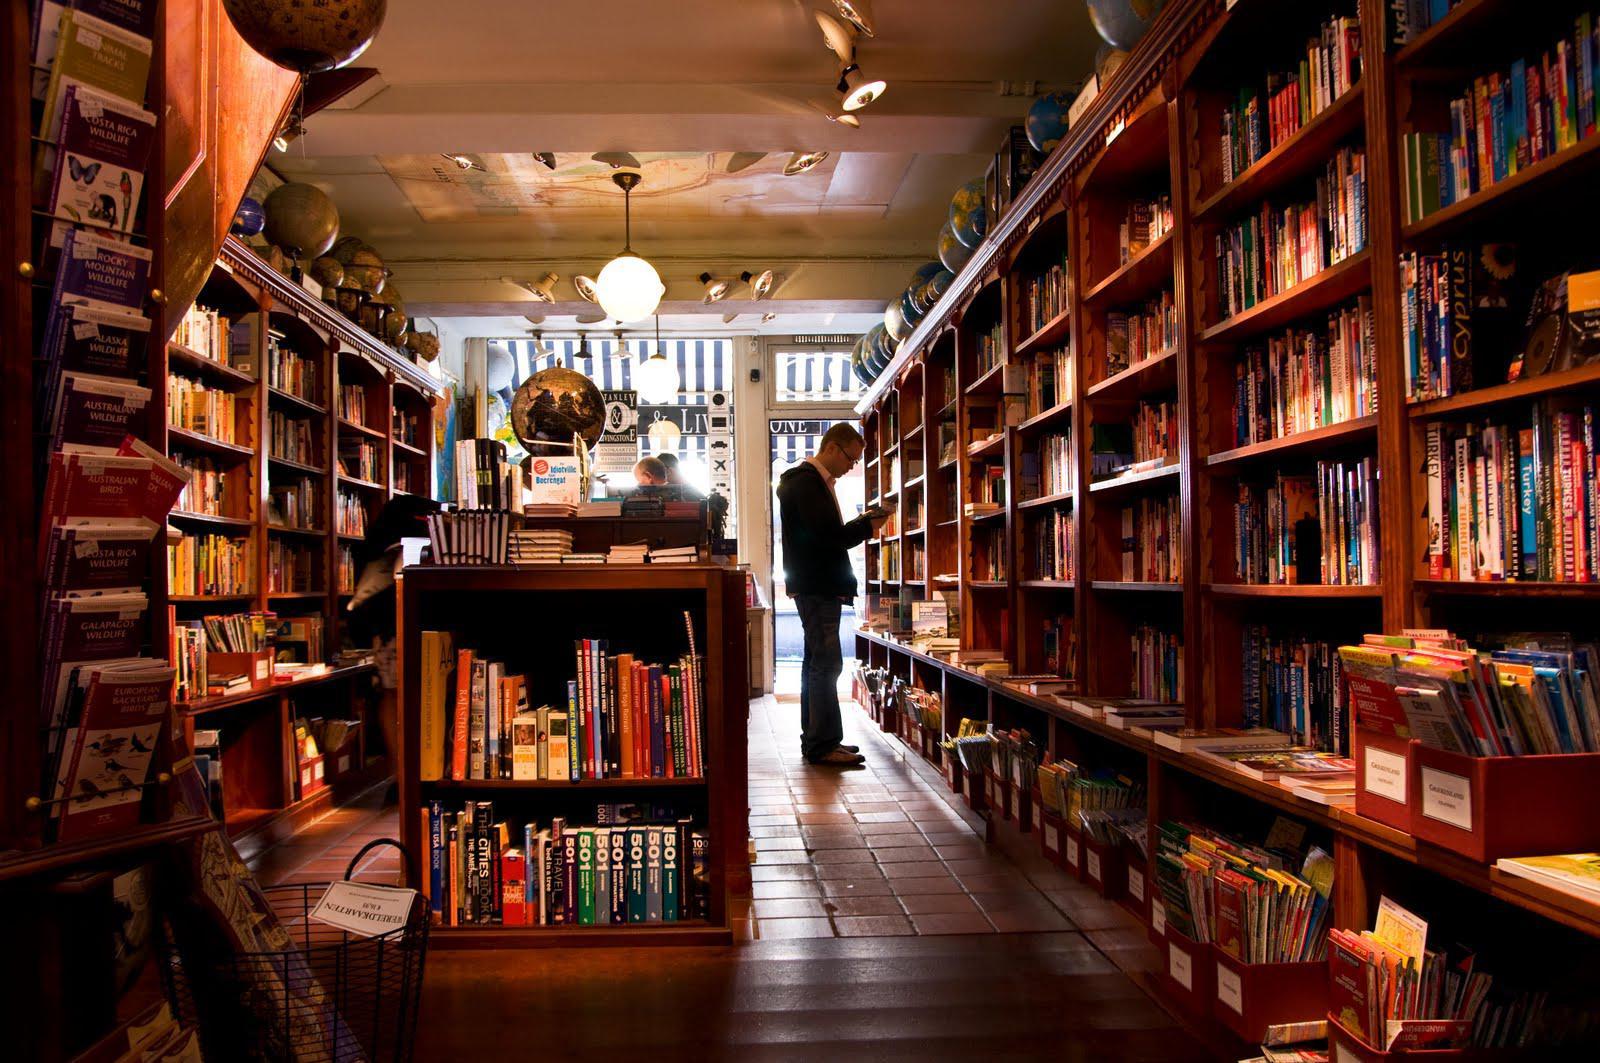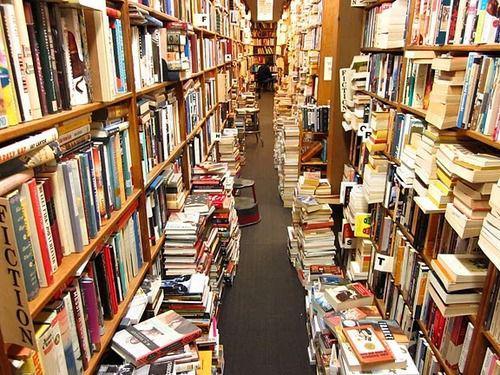The first image is the image on the left, the second image is the image on the right. For the images shown, is this caption "There are at least 4 people" true? Answer yes or no. No. 